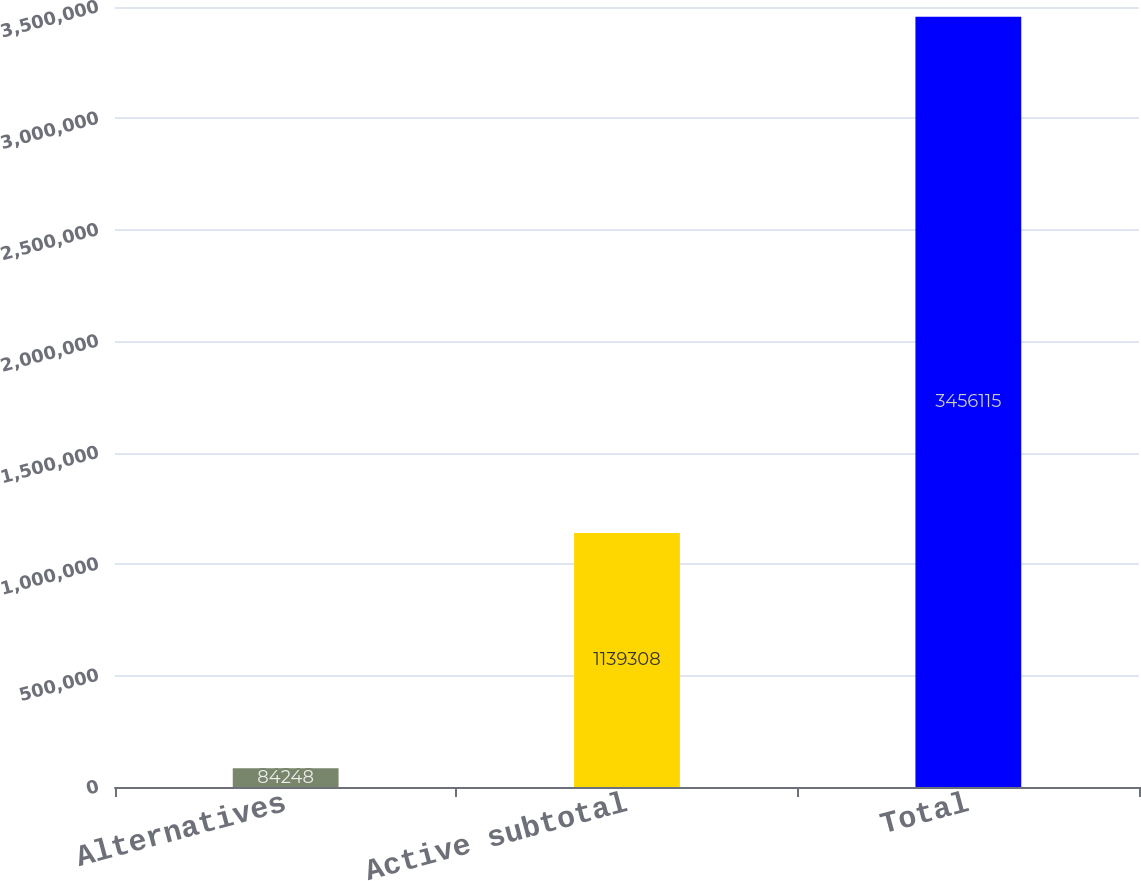Convert chart. <chart><loc_0><loc_0><loc_500><loc_500><bar_chart><fcel>Alternatives<fcel>Active subtotal<fcel>Total<nl><fcel>84248<fcel>1.13931e+06<fcel>3.45612e+06<nl></chart> 